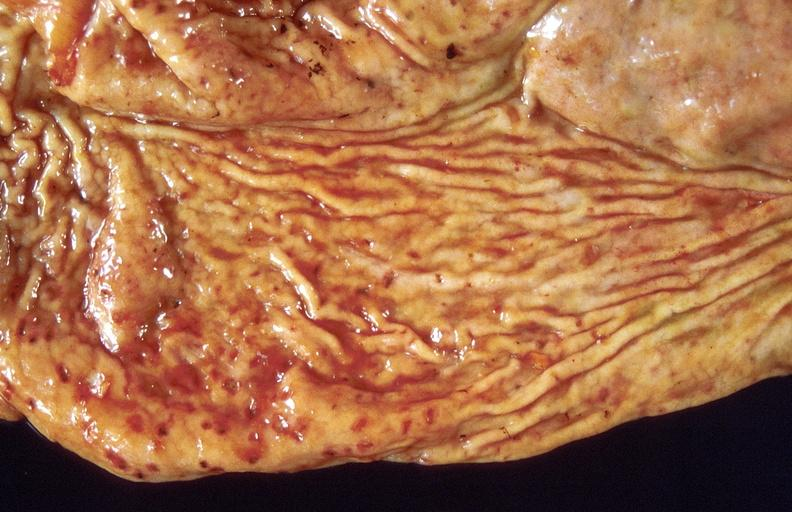does this image show stress ulcers, stomach?
Answer the question using a single word or phrase. Yes 